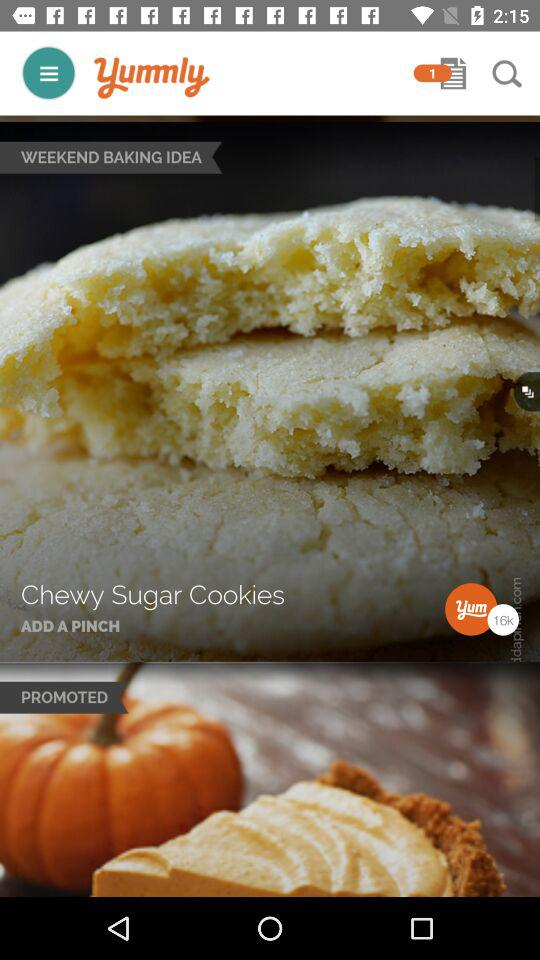What is the name of the cookie? The name of the cookie is "Chewy Sugar Cookies". 